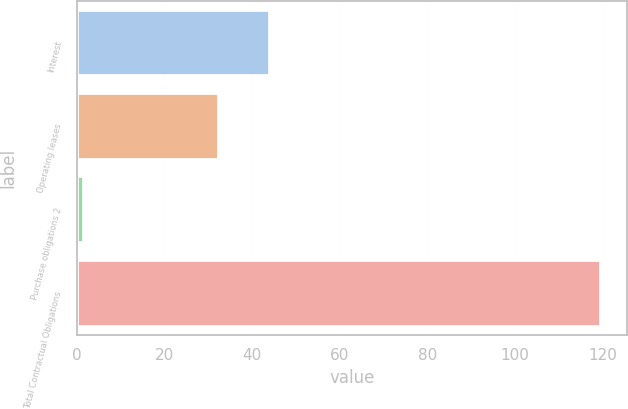Convert chart. <chart><loc_0><loc_0><loc_500><loc_500><bar_chart><fcel>Interest<fcel>Operating leases<fcel>Purchase obligations 2<fcel>Total Contractual Obligations<nl><fcel>44.19<fcel>32.4<fcel>1.7<fcel>119.6<nl></chart> 